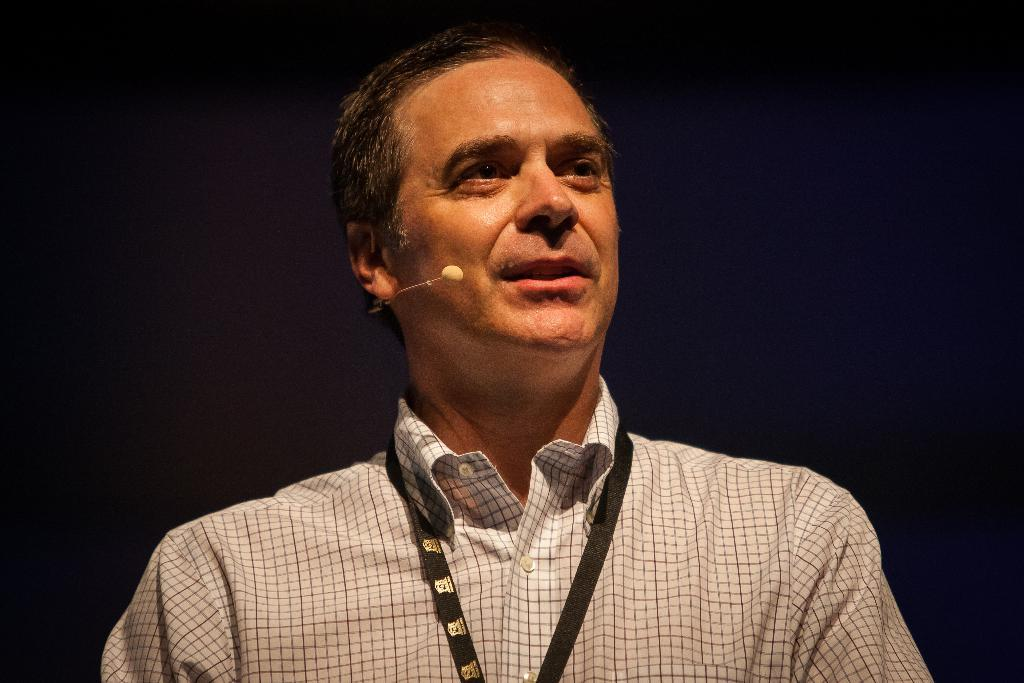Who is the main subject in the image? There is a man in the image. What object is the man holding in the image? The man is holding a microphone (mike) in the image. What is the man wearing in the image? The man is wearing a checked shirt in the image. Does the man have any identification in the image? Yes, the man has an ID card in the image. What is the color of the background in the image? The background of the image is black. What type of fowl can be seen in the image? There is no fowl present in the image; it features a man holding a microphone and wearing a checked shirt. Can you tell me how many women are in the image? There is no woman present in the image; it features a man as the main subject. 